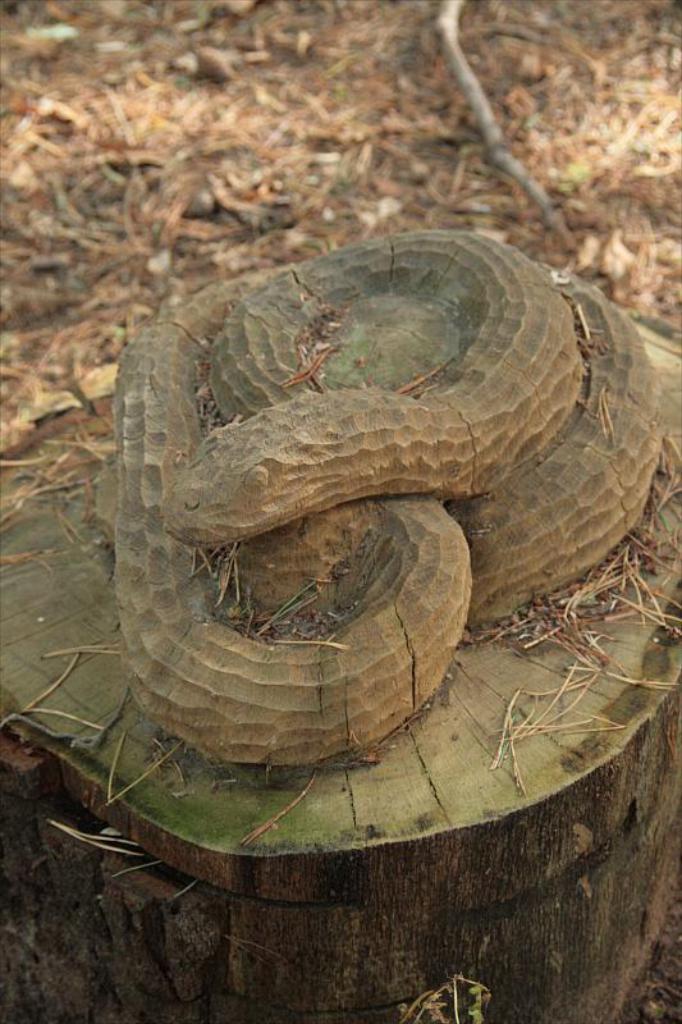Please provide a concise description of this image. In this image there is a snake sculpture on the wooden trunk. Behind it there's grass on the land. 